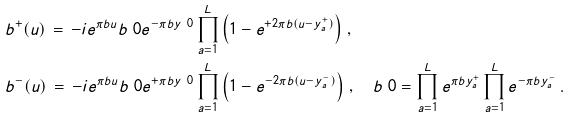Convert formula to latex. <formula><loc_0><loc_0><loc_500><loc_500>& b ^ { + } ( u ) \, = \, - i e ^ { \pi b u } b _ { \ } 0 e ^ { - \pi b y _ { \ } 0 } \prod _ { a = 1 } ^ { L } \left ( 1 - e ^ { + 2 \pi b ( u - y _ { a } ^ { + } ) } \right ) \, , \\ & b ^ { - } ( u ) \, = \, - i e ^ { \pi b u } b _ { \ } 0 e ^ { + \pi b y _ { \ } 0 } \prod _ { a = 1 } ^ { L } \left ( 1 - e ^ { - 2 \pi b ( u - y _ { a } ^ { - } ) } \right ) \, , \quad b _ { \ } 0 = \prod _ { a = 1 } ^ { L } e ^ { \pi b y _ { a } ^ { + } } \prod _ { a = 1 } ^ { L } e ^ { - \pi b y _ { a } ^ { - } } \, .</formula> 